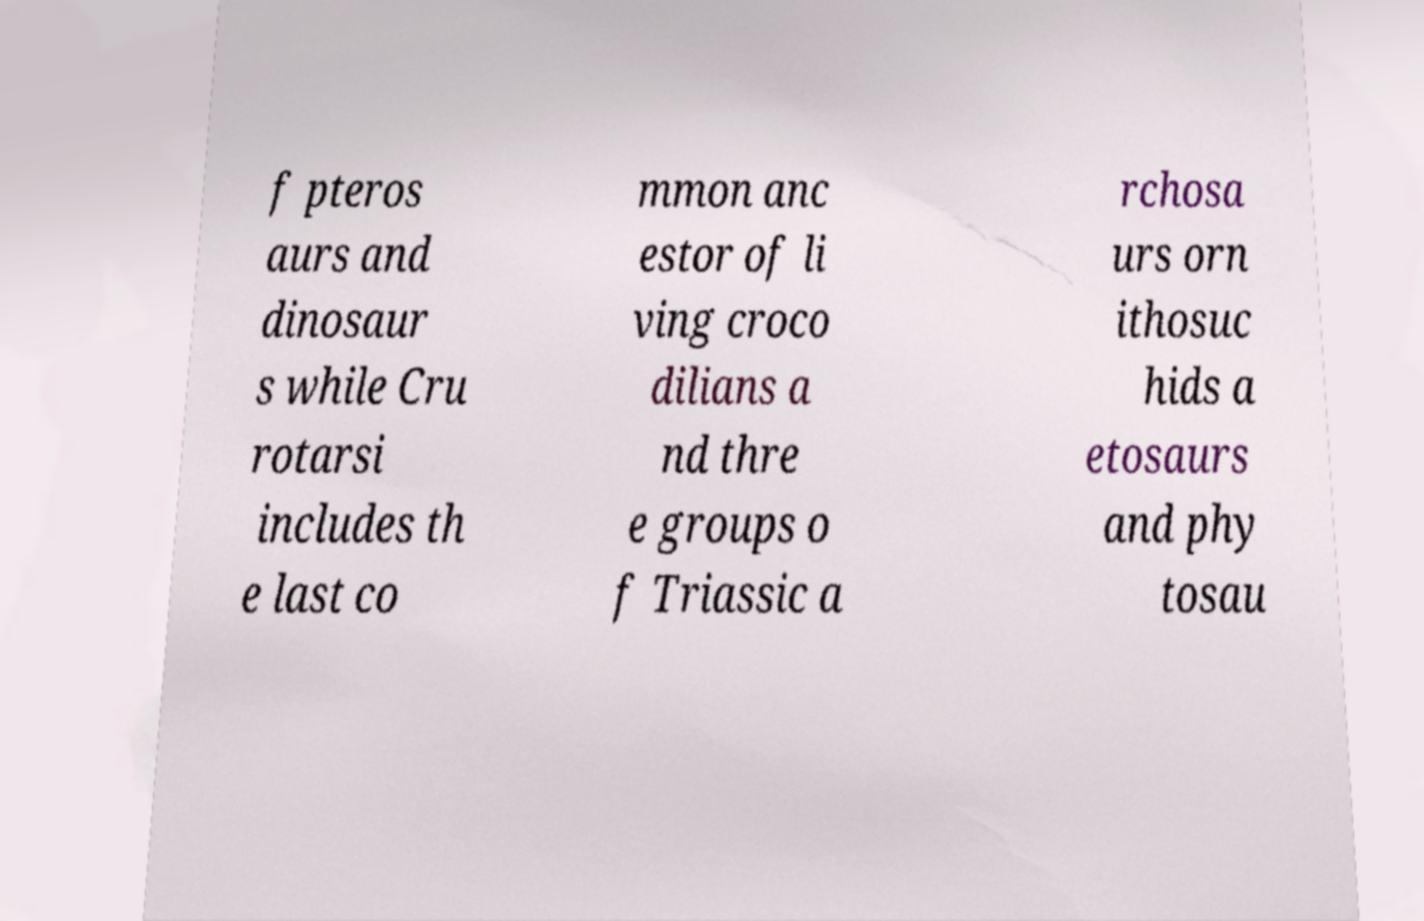What messages or text are displayed in this image? I need them in a readable, typed format. f pteros aurs and dinosaur s while Cru rotarsi includes th e last co mmon anc estor of li ving croco dilians a nd thre e groups o f Triassic a rchosa urs orn ithosuc hids a etosaurs and phy tosau 